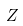Convert formula to latex. <formula><loc_0><loc_0><loc_500><loc_500>Z</formula> 